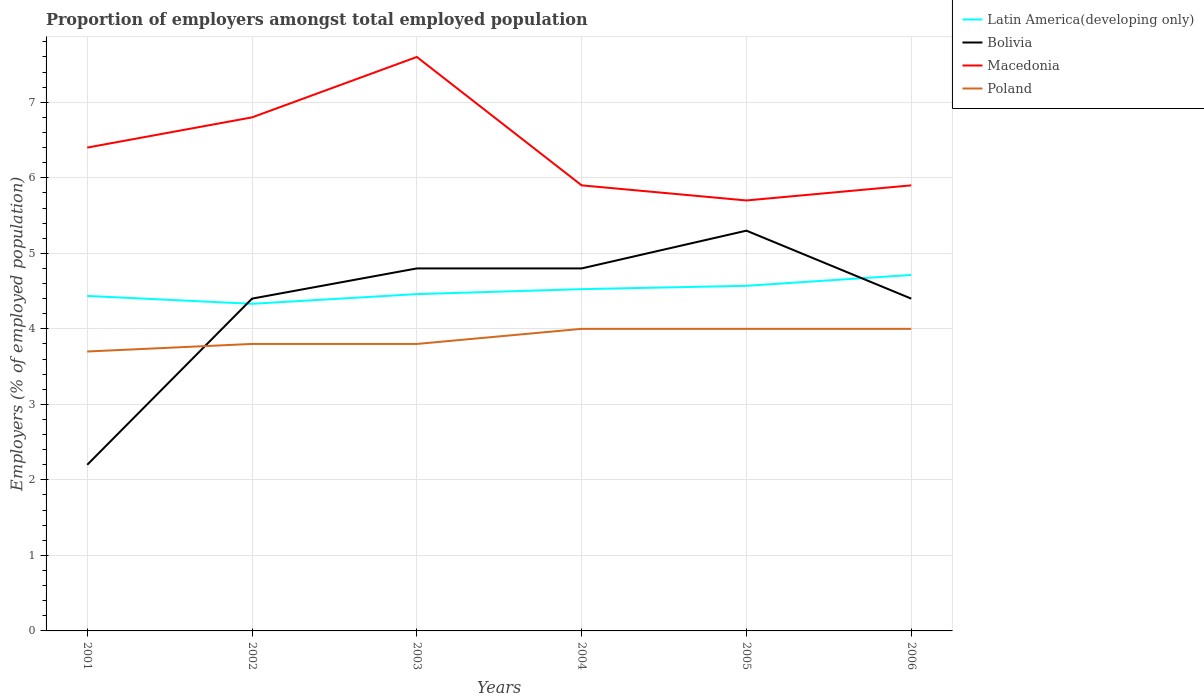Does the line corresponding to Poland intersect with the line corresponding to Macedonia?
Provide a short and direct response. No. Across all years, what is the maximum proportion of employers in Latin America(developing only)?
Provide a short and direct response. 4.33. In which year was the proportion of employers in Macedonia maximum?
Your answer should be compact. 2005. What is the total proportion of employers in Poland in the graph?
Your answer should be very brief. -0.2. What is the difference between the highest and the second highest proportion of employers in Poland?
Make the answer very short. 0.3. Is the proportion of employers in Bolivia strictly greater than the proportion of employers in Latin America(developing only) over the years?
Offer a terse response. No. What is the difference between two consecutive major ticks on the Y-axis?
Offer a terse response. 1. Does the graph contain any zero values?
Ensure brevity in your answer.  No. Does the graph contain grids?
Your answer should be compact. Yes. Where does the legend appear in the graph?
Provide a short and direct response. Top right. How are the legend labels stacked?
Your answer should be compact. Vertical. What is the title of the graph?
Give a very brief answer. Proportion of employers amongst total employed population. What is the label or title of the X-axis?
Make the answer very short. Years. What is the label or title of the Y-axis?
Offer a very short reply. Employers (% of employed population). What is the Employers (% of employed population) in Latin America(developing only) in 2001?
Your answer should be compact. 4.44. What is the Employers (% of employed population) of Bolivia in 2001?
Your response must be concise. 2.2. What is the Employers (% of employed population) of Macedonia in 2001?
Your response must be concise. 6.4. What is the Employers (% of employed population) of Poland in 2001?
Your response must be concise. 3.7. What is the Employers (% of employed population) of Latin America(developing only) in 2002?
Keep it short and to the point. 4.33. What is the Employers (% of employed population) of Bolivia in 2002?
Offer a terse response. 4.4. What is the Employers (% of employed population) of Macedonia in 2002?
Your response must be concise. 6.8. What is the Employers (% of employed population) of Poland in 2002?
Your answer should be very brief. 3.8. What is the Employers (% of employed population) of Latin America(developing only) in 2003?
Give a very brief answer. 4.46. What is the Employers (% of employed population) of Bolivia in 2003?
Your response must be concise. 4.8. What is the Employers (% of employed population) in Macedonia in 2003?
Your response must be concise. 7.6. What is the Employers (% of employed population) in Poland in 2003?
Keep it short and to the point. 3.8. What is the Employers (% of employed population) in Latin America(developing only) in 2004?
Offer a very short reply. 4.53. What is the Employers (% of employed population) of Bolivia in 2004?
Your response must be concise. 4.8. What is the Employers (% of employed population) in Macedonia in 2004?
Your response must be concise. 5.9. What is the Employers (% of employed population) of Latin America(developing only) in 2005?
Offer a terse response. 4.57. What is the Employers (% of employed population) in Bolivia in 2005?
Your response must be concise. 5.3. What is the Employers (% of employed population) in Macedonia in 2005?
Provide a short and direct response. 5.7. What is the Employers (% of employed population) of Latin America(developing only) in 2006?
Provide a short and direct response. 4.71. What is the Employers (% of employed population) in Bolivia in 2006?
Your answer should be compact. 4.4. What is the Employers (% of employed population) in Macedonia in 2006?
Give a very brief answer. 5.9. Across all years, what is the maximum Employers (% of employed population) of Latin America(developing only)?
Provide a short and direct response. 4.71. Across all years, what is the maximum Employers (% of employed population) in Bolivia?
Ensure brevity in your answer.  5.3. Across all years, what is the maximum Employers (% of employed population) in Macedonia?
Ensure brevity in your answer.  7.6. Across all years, what is the minimum Employers (% of employed population) in Latin America(developing only)?
Your answer should be compact. 4.33. Across all years, what is the minimum Employers (% of employed population) in Bolivia?
Offer a very short reply. 2.2. Across all years, what is the minimum Employers (% of employed population) of Macedonia?
Your answer should be very brief. 5.7. Across all years, what is the minimum Employers (% of employed population) of Poland?
Provide a succinct answer. 3.7. What is the total Employers (% of employed population) in Latin America(developing only) in the graph?
Keep it short and to the point. 27.04. What is the total Employers (% of employed population) in Bolivia in the graph?
Make the answer very short. 25.9. What is the total Employers (% of employed population) of Macedonia in the graph?
Your answer should be compact. 38.3. What is the total Employers (% of employed population) in Poland in the graph?
Your answer should be compact. 23.3. What is the difference between the Employers (% of employed population) in Latin America(developing only) in 2001 and that in 2002?
Offer a very short reply. 0.1. What is the difference between the Employers (% of employed population) of Bolivia in 2001 and that in 2002?
Provide a succinct answer. -2.2. What is the difference between the Employers (% of employed population) in Latin America(developing only) in 2001 and that in 2003?
Ensure brevity in your answer.  -0.02. What is the difference between the Employers (% of employed population) in Macedonia in 2001 and that in 2003?
Your response must be concise. -1.2. What is the difference between the Employers (% of employed population) of Poland in 2001 and that in 2003?
Keep it short and to the point. -0.1. What is the difference between the Employers (% of employed population) in Latin America(developing only) in 2001 and that in 2004?
Offer a very short reply. -0.09. What is the difference between the Employers (% of employed population) of Macedonia in 2001 and that in 2004?
Ensure brevity in your answer.  0.5. What is the difference between the Employers (% of employed population) of Latin America(developing only) in 2001 and that in 2005?
Provide a succinct answer. -0.13. What is the difference between the Employers (% of employed population) in Latin America(developing only) in 2001 and that in 2006?
Your response must be concise. -0.28. What is the difference between the Employers (% of employed population) of Bolivia in 2001 and that in 2006?
Offer a very short reply. -2.2. What is the difference between the Employers (% of employed population) in Poland in 2001 and that in 2006?
Your response must be concise. -0.3. What is the difference between the Employers (% of employed population) in Latin America(developing only) in 2002 and that in 2003?
Provide a short and direct response. -0.13. What is the difference between the Employers (% of employed population) in Poland in 2002 and that in 2003?
Your answer should be very brief. 0. What is the difference between the Employers (% of employed population) in Latin America(developing only) in 2002 and that in 2004?
Your answer should be very brief. -0.19. What is the difference between the Employers (% of employed population) in Macedonia in 2002 and that in 2004?
Your response must be concise. 0.9. What is the difference between the Employers (% of employed population) in Poland in 2002 and that in 2004?
Your response must be concise. -0.2. What is the difference between the Employers (% of employed population) of Latin America(developing only) in 2002 and that in 2005?
Provide a succinct answer. -0.24. What is the difference between the Employers (% of employed population) of Latin America(developing only) in 2002 and that in 2006?
Your answer should be compact. -0.38. What is the difference between the Employers (% of employed population) of Bolivia in 2002 and that in 2006?
Your answer should be compact. 0. What is the difference between the Employers (% of employed population) of Macedonia in 2002 and that in 2006?
Your answer should be compact. 0.9. What is the difference between the Employers (% of employed population) of Latin America(developing only) in 2003 and that in 2004?
Your answer should be very brief. -0.07. What is the difference between the Employers (% of employed population) of Bolivia in 2003 and that in 2004?
Your answer should be very brief. 0. What is the difference between the Employers (% of employed population) of Latin America(developing only) in 2003 and that in 2005?
Keep it short and to the point. -0.11. What is the difference between the Employers (% of employed population) in Bolivia in 2003 and that in 2005?
Provide a short and direct response. -0.5. What is the difference between the Employers (% of employed population) in Macedonia in 2003 and that in 2005?
Offer a very short reply. 1.9. What is the difference between the Employers (% of employed population) in Poland in 2003 and that in 2005?
Your answer should be compact. -0.2. What is the difference between the Employers (% of employed population) of Latin America(developing only) in 2003 and that in 2006?
Ensure brevity in your answer.  -0.25. What is the difference between the Employers (% of employed population) in Bolivia in 2003 and that in 2006?
Provide a succinct answer. 0.4. What is the difference between the Employers (% of employed population) of Macedonia in 2003 and that in 2006?
Your response must be concise. 1.7. What is the difference between the Employers (% of employed population) in Poland in 2003 and that in 2006?
Offer a very short reply. -0.2. What is the difference between the Employers (% of employed population) in Latin America(developing only) in 2004 and that in 2005?
Provide a succinct answer. -0.04. What is the difference between the Employers (% of employed population) in Bolivia in 2004 and that in 2005?
Give a very brief answer. -0.5. What is the difference between the Employers (% of employed population) in Latin America(developing only) in 2004 and that in 2006?
Your response must be concise. -0.19. What is the difference between the Employers (% of employed population) in Macedonia in 2004 and that in 2006?
Offer a very short reply. 0. What is the difference between the Employers (% of employed population) of Latin America(developing only) in 2005 and that in 2006?
Offer a very short reply. -0.14. What is the difference between the Employers (% of employed population) of Bolivia in 2005 and that in 2006?
Provide a succinct answer. 0.9. What is the difference between the Employers (% of employed population) in Latin America(developing only) in 2001 and the Employers (% of employed population) in Bolivia in 2002?
Provide a succinct answer. 0.04. What is the difference between the Employers (% of employed population) of Latin America(developing only) in 2001 and the Employers (% of employed population) of Macedonia in 2002?
Offer a very short reply. -2.36. What is the difference between the Employers (% of employed population) in Latin America(developing only) in 2001 and the Employers (% of employed population) in Poland in 2002?
Make the answer very short. 0.64. What is the difference between the Employers (% of employed population) of Bolivia in 2001 and the Employers (% of employed population) of Macedonia in 2002?
Provide a succinct answer. -4.6. What is the difference between the Employers (% of employed population) in Macedonia in 2001 and the Employers (% of employed population) in Poland in 2002?
Keep it short and to the point. 2.6. What is the difference between the Employers (% of employed population) of Latin America(developing only) in 2001 and the Employers (% of employed population) of Bolivia in 2003?
Give a very brief answer. -0.36. What is the difference between the Employers (% of employed population) of Latin America(developing only) in 2001 and the Employers (% of employed population) of Macedonia in 2003?
Ensure brevity in your answer.  -3.16. What is the difference between the Employers (% of employed population) in Latin America(developing only) in 2001 and the Employers (% of employed population) in Poland in 2003?
Offer a very short reply. 0.64. What is the difference between the Employers (% of employed population) in Bolivia in 2001 and the Employers (% of employed population) in Macedonia in 2003?
Offer a very short reply. -5.4. What is the difference between the Employers (% of employed population) in Bolivia in 2001 and the Employers (% of employed population) in Poland in 2003?
Your response must be concise. -1.6. What is the difference between the Employers (% of employed population) in Macedonia in 2001 and the Employers (% of employed population) in Poland in 2003?
Make the answer very short. 2.6. What is the difference between the Employers (% of employed population) in Latin America(developing only) in 2001 and the Employers (% of employed population) in Bolivia in 2004?
Your response must be concise. -0.36. What is the difference between the Employers (% of employed population) of Latin America(developing only) in 2001 and the Employers (% of employed population) of Macedonia in 2004?
Your answer should be very brief. -1.46. What is the difference between the Employers (% of employed population) in Latin America(developing only) in 2001 and the Employers (% of employed population) in Poland in 2004?
Your response must be concise. 0.44. What is the difference between the Employers (% of employed population) of Bolivia in 2001 and the Employers (% of employed population) of Poland in 2004?
Offer a terse response. -1.8. What is the difference between the Employers (% of employed population) of Latin America(developing only) in 2001 and the Employers (% of employed population) of Bolivia in 2005?
Give a very brief answer. -0.86. What is the difference between the Employers (% of employed population) of Latin America(developing only) in 2001 and the Employers (% of employed population) of Macedonia in 2005?
Ensure brevity in your answer.  -1.26. What is the difference between the Employers (% of employed population) in Latin America(developing only) in 2001 and the Employers (% of employed population) in Poland in 2005?
Make the answer very short. 0.44. What is the difference between the Employers (% of employed population) of Macedonia in 2001 and the Employers (% of employed population) of Poland in 2005?
Make the answer very short. 2.4. What is the difference between the Employers (% of employed population) of Latin America(developing only) in 2001 and the Employers (% of employed population) of Bolivia in 2006?
Your answer should be compact. 0.04. What is the difference between the Employers (% of employed population) of Latin America(developing only) in 2001 and the Employers (% of employed population) of Macedonia in 2006?
Your response must be concise. -1.46. What is the difference between the Employers (% of employed population) of Latin America(developing only) in 2001 and the Employers (% of employed population) of Poland in 2006?
Provide a short and direct response. 0.44. What is the difference between the Employers (% of employed population) in Bolivia in 2001 and the Employers (% of employed population) in Macedonia in 2006?
Provide a succinct answer. -3.7. What is the difference between the Employers (% of employed population) in Macedonia in 2001 and the Employers (% of employed population) in Poland in 2006?
Ensure brevity in your answer.  2.4. What is the difference between the Employers (% of employed population) in Latin America(developing only) in 2002 and the Employers (% of employed population) in Bolivia in 2003?
Give a very brief answer. -0.47. What is the difference between the Employers (% of employed population) of Latin America(developing only) in 2002 and the Employers (% of employed population) of Macedonia in 2003?
Provide a succinct answer. -3.27. What is the difference between the Employers (% of employed population) in Latin America(developing only) in 2002 and the Employers (% of employed population) in Poland in 2003?
Ensure brevity in your answer.  0.53. What is the difference between the Employers (% of employed population) of Bolivia in 2002 and the Employers (% of employed population) of Poland in 2003?
Give a very brief answer. 0.6. What is the difference between the Employers (% of employed population) of Macedonia in 2002 and the Employers (% of employed population) of Poland in 2003?
Keep it short and to the point. 3. What is the difference between the Employers (% of employed population) in Latin America(developing only) in 2002 and the Employers (% of employed population) in Bolivia in 2004?
Your answer should be compact. -0.47. What is the difference between the Employers (% of employed population) of Latin America(developing only) in 2002 and the Employers (% of employed population) of Macedonia in 2004?
Provide a short and direct response. -1.57. What is the difference between the Employers (% of employed population) in Latin America(developing only) in 2002 and the Employers (% of employed population) in Poland in 2004?
Your response must be concise. 0.33. What is the difference between the Employers (% of employed population) of Bolivia in 2002 and the Employers (% of employed population) of Macedonia in 2004?
Offer a terse response. -1.5. What is the difference between the Employers (% of employed population) of Bolivia in 2002 and the Employers (% of employed population) of Poland in 2004?
Offer a very short reply. 0.4. What is the difference between the Employers (% of employed population) of Macedonia in 2002 and the Employers (% of employed population) of Poland in 2004?
Provide a succinct answer. 2.8. What is the difference between the Employers (% of employed population) in Latin America(developing only) in 2002 and the Employers (% of employed population) in Bolivia in 2005?
Ensure brevity in your answer.  -0.97. What is the difference between the Employers (% of employed population) of Latin America(developing only) in 2002 and the Employers (% of employed population) of Macedonia in 2005?
Give a very brief answer. -1.37. What is the difference between the Employers (% of employed population) in Latin America(developing only) in 2002 and the Employers (% of employed population) in Poland in 2005?
Offer a terse response. 0.33. What is the difference between the Employers (% of employed population) of Bolivia in 2002 and the Employers (% of employed population) of Macedonia in 2005?
Keep it short and to the point. -1.3. What is the difference between the Employers (% of employed population) of Bolivia in 2002 and the Employers (% of employed population) of Poland in 2005?
Provide a short and direct response. 0.4. What is the difference between the Employers (% of employed population) in Latin America(developing only) in 2002 and the Employers (% of employed population) in Bolivia in 2006?
Provide a short and direct response. -0.07. What is the difference between the Employers (% of employed population) of Latin America(developing only) in 2002 and the Employers (% of employed population) of Macedonia in 2006?
Your response must be concise. -1.57. What is the difference between the Employers (% of employed population) of Latin America(developing only) in 2002 and the Employers (% of employed population) of Poland in 2006?
Keep it short and to the point. 0.33. What is the difference between the Employers (% of employed population) in Bolivia in 2002 and the Employers (% of employed population) in Macedonia in 2006?
Your response must be concise. -1.5. What is the difference between the Employers (% of employed population) in Latin America(developing only) in 2003 and the Employers (% of employed population) in Bolivia in 2004?
Keep it short and to the point. -0.34. What is the difference between the Employers (% of employed population) in Latin America(developing only) in 2003 and the Employers (% of employed population) in Macedonia in 2004?
Offer a terse response. -1.44. What is the difference between the Employers (% of employed population) in Latin America(developing only) in 2003 and the Employers (% of employed population) in Poland in 2004?
Provide a short and direct response. 0.46. What is the difference between the Employers (% of employed population) in Bolivia in 2003 and the Employers (% of employed population) in Macedonia in 2004?
Give a very brief answer. -1.1. What is the difference between the Employers (% of employed population) of Latin America(developing only) in 2003 and the Employers (% of employed population) of Bolivia in 2005?
Give a very brief answer. -0.84. What is the difference between the Employers (% of employed population) of Latin America(developing only) in 2003 and the Employers (% of employed population) of Macedonia in 2005?
Your response must be concise. -1.24. What is the difference between the Employers (% of employed population) in Latin America(developing only) in 2003 and the Employers (% of employed population) in Poland in 2005?
Your response must be concise. 0.46. What is the difference between the Employers (% of employed population) of Bolivia in 2003 and the Employers (% of employed population) of Macedonia in 2005?
Keep it short and to the point. -0.9. What is the difference between the Employers (% of employed population) of Macedonia in 2003 and the Employers (% of employed population) of Poland in 2005?
Give a very brief answer. 3.6. What is the difference between the Employers (% of employed population) in Latin America(developing only) in 2003 and the Employers (% of employed population) in Bolivia in 2006?
Make the answer very short. 0.06. What is the difference between the Employers (% of employed population) in Latin America(developing only) in 2003 and the Employers (% of employed population) in Macedonia in 2006?
Make the answer very short. -1.44. What is the difference between the Employers (% of employed population) in Latin America(developing only) in 2003 and the Employers (% of employed population) in Poland in 2006?
Your response must be concise. 0.46. What is the difference between the Employers (% of employed population) of Latin America(developing only) in 2004 and the Employers (% of employed population) of Bolivia in 2005?
Ensure brevity in your answer.  -0.77. What is the difference between the Employers (% of employed population) in Latin America(developing only) in 2004 and the Employers (% of employed population) in Macedonia in 2005?
Offer a very short reply. -1.17. What is the difference between the Employers (% of employed population) of Latin America(developing only) in 2004 and the Employers (% of employed population) of Poland in 2005?
Make the answer very short. 0.53. What is the difference between the Employers (% of employed population) of Bolivia in 2004 and the Employers (% of employed population) of Poland in 2005?
Offer a terse response. 0.8. What is the difference between the Employers (% of employed population) of Latin America(developing only) in 2004 and the Employers (% of employed population) of Bolivia in 2006?
Ensure brevity in your answer.  0.13. What is the difference between the Employers (% of employed population) in Latin America(developing only) in 2004 and the Employers (% of employed population) in Macedonia in 2006?
Provide a succinct answer. -1.37. What is the difference between the Employers (% of employed population) of Latin America(developing only) in 2004 and the Employers (% of employed population) of Poland in 2006?
Your response must be concise. 0.53. What is the difference between the Employers (% of employed population) in Bolivia in 2004 and the Employers (% of employed population) in Poland in 2006?
Your answer should be compact. 0.8. What is the difference between the Employers (% of employed population) of Macedonia in 2004 and the Employers (% of employed population) of Poland in 2006?
Provide a succinct answer. 1.9. What is the difference between the Employers (% of employed population) in Latin America(developing only) in 2005 and the Employers (% of employed population) in Bolivia in 2006?
Offer a terse response. 0.17. What is the difference between the Employers (% of employed population) in Latin America(developing only) in 2005 and the Employers (% of employed population) in Macedonia in 2006?
Your answer should be very brief. -1.33. What is the difference between the Employers (% of employed population) in Latin America(developing only) in 2005 and the Employers (% of employed population) in Poland in 2006?
Keep it short and to the point. 0.57. What is the average Employers (% of employed population) in Latin America(developing only) per year?
Offer a terse response. 4.51. What is the average Employers (% of employed population) of Bolivia per year?
Ensure brevity in your answer.  4.32. What is the average Employers (% of employed population) of Macedonia per year?
Your response must be concise. 6.38. What is the average Employers (% of employed population) of Poland per year?
Offer a terse response. 3.88. In the year 2001, what is the difference between the Employers (% of employed population) in Latin America(developing only) and Employers (% of employed population) in Bolivia?
Your answer should be very brief. 2.24. In the year 2001, what is the difference between the Employers (% of employed population) in Latin America(developing only) and Employers (% of employed population) in Macedonia?
Ensure brevity in your answer.  -1.96. In the year 2001, what is the difference between the Employers (% of employed population) in Latin America(developing only) and Employers (% of employed population) in Poland?
Provide a short and direct response. 0.74. In the year 2001, what is the difference between the Employers (% of employed population) of Bolivia and Employers (% of employed population) of Poland?
Your answer should be very brief. -1.5. In the year 2001, what is the difference between the Employers (% of employed population) of Macedonia and Employers (% of employed population) of Poland?
Give a very brief answer. 2.7. In the year 2002, what is the difference between the Employers (% of employed population) of Latin America(developing only) and Employers (% of employed population) of Bolivia?
Keep it short and to the point. -0.07. In the year 2002, what is the difference between the Employers (% of employed population) of Latin America(developing only) and Employers (% of employed population) of Macedonia?
Ensure brevity in your answer.  -2.47. In the year 2002, what is the difference between the Employers (% of employed population) of Latin America(developing only) and Employers (% of employed population) of Poland?
Provide a short and direct response. 0.53. In the year 2002, what is the difference between the Employers (% of employed population) of Bolivia and Employers (% of employed population) of Macedonia?
Make the answer very short. -2.4. In the year 2003, what is the difference between the Employers (% of employed population) in Latin America(developing only) and Employers (% of employed population) in Bolivia?
Keep it short and to the point. -0.34. In the year 2003, what is the difference between the Employers (% of employed population) of Latin America(developing only) and Employers (% of employed population) of Macedonia?
Provide a short and direct response. -3.14. In the year 2003, what is the difference between the Employers (% of employed population) in Latin America(developing only) and Employers (% of employed population) in Poland?
Your answer should be compact. 0.66. In the year 2003, what is the difference between the Employers (% of employed population) in Bolivia and Employers (% of employed population) in Macedonia?
Your answer should be very brief. -2.8. In the year 2003, what is the difference between the Employers (% of employed population) of Bolivia and Employers (% of employed population) of Poland?
Your answer should be very brief. 1. In the year 2004, what is the difference between the Employers (% of employed population) of Latin America(developing only) and Employers (% of employed population) of Bolivia?
Make the answer very short. -0.27. In the year 2004, what is the difference between the Employers (% of employed population) of Latin America(developing only) and Employers (% of employed population) of Macedonia?
Ensure brevity in your answer.  -1.37. In the year 2004, what is the difference between the Employers (% of employed population) of Latin America(developing only) and Employers (% of employed population) of Poland?
Your answer should be compact. 0.53. In the year 2004, what is the difference between the Employers (% of employed population) of Bolivia and Employers (% of employed population) of Poland?
Give a very brief answer. 0.8. In the year 2004, what is the difference between the Employers (% of employed population) of Macedonia and Employers (% of employed population) of Poland?
Give a very brief answer. 1.9. In the year 2005, what is the difference between the Employers (% of employed population) in Latin America(developing only) and Employers (% of employed population) in Bolivia?
Ensure brevity in your answer.  -0.73. In the year 2005, what is the difference between the Employers (% of employed population) in Latin America(developing only) and Employers (% of employed population) in Macedonia?
Your answer should be compact. -1.13. In the year 2005, what is the difference between the Employers (% of employed population) in Latin America(developing only) and Employers (% of employed population) in Poland?
Make the answer very short. 0.57. In the year 2005, what is the difference between the Employers (% of employed population) in Bolivia and Employers (% of employed population) in Poland?
Keep it short and to the point. 1.3. In the year 2005, what is the difference between the Employers (% of employed population) in Macedonia and Employers (% of employed population) in Poland?
Give a very brief answer. 1.7. In the year 2006, what is the difference between the Employers (% of employed population) in Latin America(developing only) and Employers (% of employed population) in Bolivia?
Your answer should be compact. 0.31. In the year 2006, what is the difference between the Employers (% of employed population) of Latin America(developing only) and Employers (% of employed population) of Macedonia?
Your response must be concise. -1.19. In the year 2006, what is the difference between the Employers (% of employed population) in Latin America(developing only) and Employers (% of employed population) in Poland?
Offer a very short reply. 0.71. In the year 2006, what is the difference between the Employers (% of employed population) in Bolivia and Employers (% of employed population) in Macedonia?
Keep it short and to the point. -1.5. In the year 2006, what is the difference between the Employers (% of employed population) in Macedonia and Employers (% of employed population) in Poland?
Provide a short and direct response. 1.9. What is the ratio of the Employers (% of employed population) in Latin America(developing only) in 2001 to that in 2002?
Provide a short and direct response. 1.02. What is the ratio of the Employers (% of employed population) of Poland in 2001 to that in 2002?
Offer a terse response. 0.97. What is the ratio of the Employers (% of employed population) of Latin America(developing only) in 2001 to that in 2003?
Offer a very short reply. 0.99. What is the ratio of the Employers (% of employed population) of Bolivia in 2001 to that in 2003?
Make the answer very short. 0.46. What is the ratio of the Employers (% of employed population) of Macedonia in 2001 to that in 2003?
Your response must be concise. 0.84. What is the ratio of the Employers (% of employed population) of Poland in 2001 to that in 2003?
Your response must be concise. 0.97. What is the ratio of the Employers (% of employed population) in Latin America(developing only) in 2001 to that in 2004?
Keep it short and to the point. 0.98. What is the ratio of the Employers (% of employed population) of Bolivia in 2001 to that in 2004?
Your answer should be compact. 0.46. What is the ratio of the Employers (% of employed population) of Macedonia in 2001 to that in 2004?
Keep it short and to the point. 1.08. What is the ratio of the Employers (% of employed population) of Poland in 2001 to that in 2004?
Make the answer very short. 0.93. What is the ratio of the Employers (% of employed population) of Latin America(developing only) in 2001 to that in 2005?
Make the answer very short. 0.97. What is the ratio of the Employers (% of employed population) in Bolivia in 2001 to that in 2005?
Ensure brevity in your answer.  0.42. What is the ratio of the Employers (% of employed population) in Macedonia in 2001 to that in 2005?
Your answer should be compact. 1.12. What is the ratio of the Employers (% of employed population) in Poland in 2001 to that in 2005?
Your answer should be very brief. 0.93. What is the ratio of the Employers (% of employed population) of Latin America(developing only) in 2001 to that in 2006?
Offer a terse response. 0.94. What is the ratio of the Employers (% of employed population) in Macedonia in 2001 to that in 2006?
Your answer should be compact. 1.08. What is the ratio of the Employers (% of employed population) of Poland in 2001 to that in 2006?
Offer a terse response. 0.93. What is the ratio of the Employers (% of employed population) in Latin America(developing only) in 2002 to that in 2003?
Provide a short and direct response. 0.97. What is the ratio of the Employers (% of employed population) in Macedonia in 2002 to that in 2003?
Provide a succinct answer. 0.89. What is the ratio of the Employers (% of employed population) of Poland in 2002 to that in 2003?
Offer a very short reply. 1. What is the ratio of the Employers (% of employed population) of Latin America(developing only) in 2002 to that in 2004?
Give a very brief answer. 0.96. What is the ratio of the Employers (% of employed population) in Macedonia in 2002 to that in 2004?
Provide a succinct answer. 1.15. What is the ratio of the Employers (% of employed population) of Poland in 2002 to that in 2004?
Your answer should be compact. 0.95. What is the ratio of the Employers (% of employed population) of Latin America(developing only) in 2002 to that in 2005?
Provide a short and direct response. 0.95. What is the ratio of the Employers (% of employed population) of Bolivia in 2002 to that in 2005?
Your answer should be very brief. 0.83. What is the ratio of the Employers (% of employed population) of Macedonia in 2002 to that in 2005?
Provide a short and direct response. 1.19. What is the ratio of the Employers (% of employed population) of Poland in 2002 to that in 2005?
Your response must be concise. 0.95. What is the ratio of the Employers (% of employed population) of Latin America(developing only) in 2002 to that in 2006?
Ensure brevity in your answer.  0.92. What is the ratio of the Employers (% of employed population) of Bolivia in 2002 to that in 2006?
Your answer should be compact. 1. What is the ratio of the Employers (% of employed population) in Macedonia in 2002 to that in 2006?
Make the answer very short. 1.15. What is the ratio of the Employers (% of employed population) of Poland in 2002 to that in 2006?
Provide a succinct answer. 0.95. What is the ratio of the Employers (% of employed population) of Latin America(developing only) in 2003 to that in 2004?
Ensure brevity in your answer.  0.99. What is the ratio of the Employers (% of employed population) of Macedonia in 2003 to that in 2004?
Your response must be concise. 1.29. What is the ratio of the Employers (% of employed population) of Latin America(developing only) in 2003 to that in 2005?
Your response must be concise. 0.98. What is the ratio of the Employers (% of employed population) of Bolivia in 2003 to that in 2005?
Provide a short and direct response. 0.91. What is the ratio of the Employers (% of employed population) in Macedonia in 2003 to that in 2005?
Make the answer very short. 1.33. What is the ratio of the Employers (% of employed population) of Poland in 2003 to that in 2005?
Provide a short and direct response. 0.95. What is the ratio of the Employers (% of employed population) in Latin America(developing only) in 2003 to that in 2006?
Ensure brevity in your answer.  0.95. What is the ratio of the Employers (% of employed population) in Bolivia in 2003 to that in 2006?
Offer a terse response. 1.09. What is the ratio of the Employers (% of employed population) in Macedonia in 2003 to that in 2006?
Offer a very short reply. 1.29. What is the ratio of the Employers (% of employed population) of Poland in 2003 to that in 2006?
Make the answer very short. 0.95. What is the ratio of the Employers (% of employed population) of Latin America(developing only) in 2004 to that in 2005?
Provide a short and direct response. 0.99. What is the ratio of the Employers (% of employed population) of Bolivia in 2004 to that in 2005?
Your answer should be compact. 0.91. What is the ratio of the Employers (% of employed population) in Macedonia in 2004 to that in 2005?
Ensure brevity in your answer.  1.04. What is the ratio of the Employers (% of employed population) of Latin America(developing only) in 2004 to that in 2006?
Keep it short and to the point. 0.96. What is the ratio of the Employers (% of employed population) in Latin America(developing only) in 2005 to that in 2006?
Provide a short and direct response. 0.97. What is the ratio of the Employers (% of employed population) of Bolivia in 2005 to that in 2006?
Keep it short and to the point. 1.2. What is the ratio of the Employers (% of employed population) of Macedonia in 2005 to that in 2006?
Your answer should be very brief. 0.97. What is the ratio of the Employers (% of employed population) of Poland in 2005 to that in 2006?
Give a very brief answer. 1. What is the difference between the highest and the second highest Employers (% of employed population) in Latin America(developing only)?
Provide a short and direct response. 0.14. What is the difference between the highest and the second highest Employers (% of employed population) in Macedonia?
Your answer should be compact. 0.8. What is the difference between the highest and the lowest Employers (% of employed population) in Latin America(developing only)?
Ensure brevity in your answer.  0.38. What is the difference between the highest and the lowest Employers (% of employed population) of Macedonia?
Your response must be concise. 1.9. 